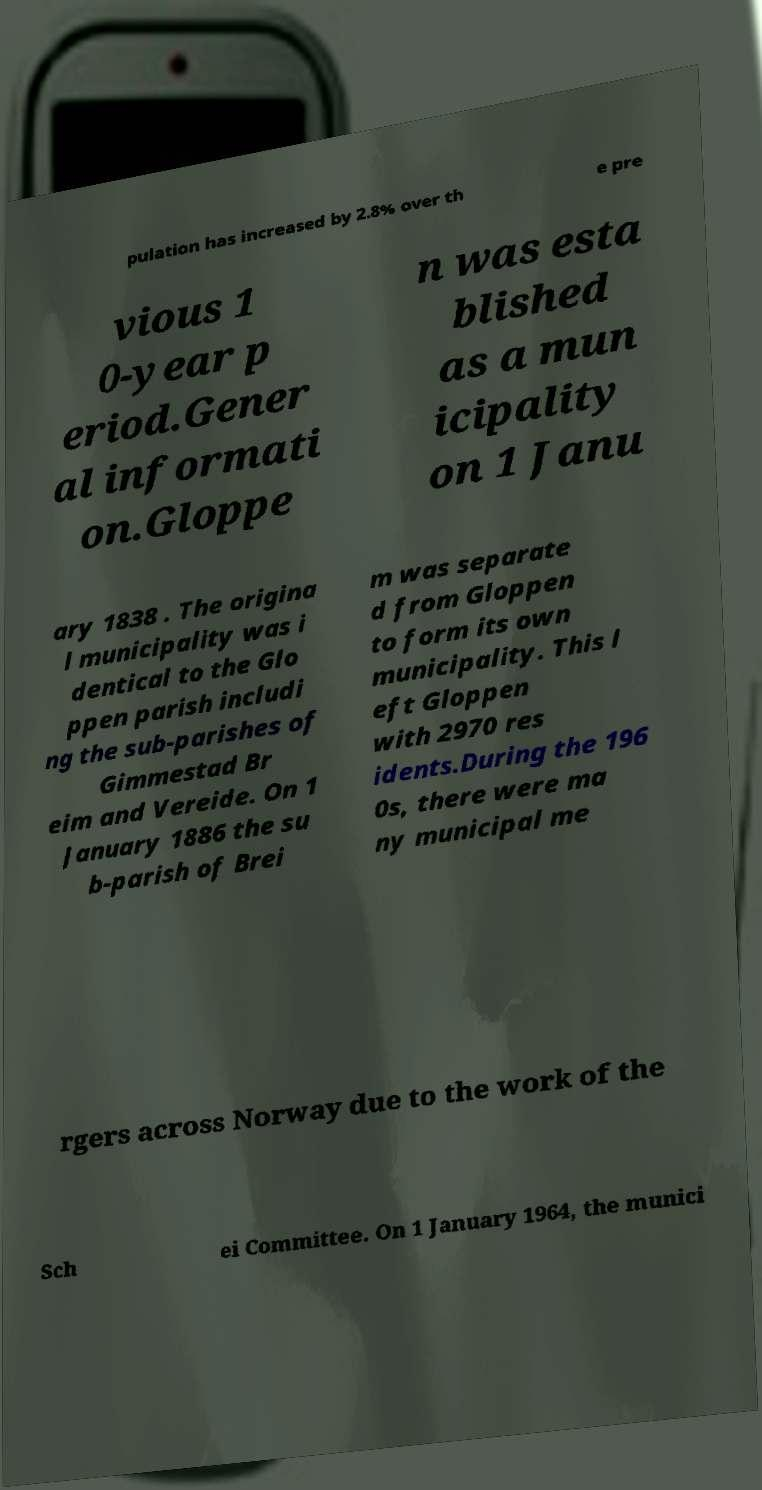Can you read and provide the text displayed in the image?This photo seems to have some interesting text. Can you extract and type it out for me? pulation has increased by 2.8% over th e pre vious 1 0-year p eriod.Gener al informati on.Gloppe n was esta blished as a mun icipality on 1 Janu ary 1838 . The origina l municipality was i dentical to the Glo ppen parish includi ng the sub-parishes of Gimmestad Br eim and Vereide. On 1 January 1886 the su b-parish of Brei m was separate d from Gloppen to form its own municipality. This l eft Gloppen with 2970 res idents.During the 196 0s, there were ma ny municipal me rgers across Norway due to the work of the Sch ei Committee. On 1 January 1964, the munici 